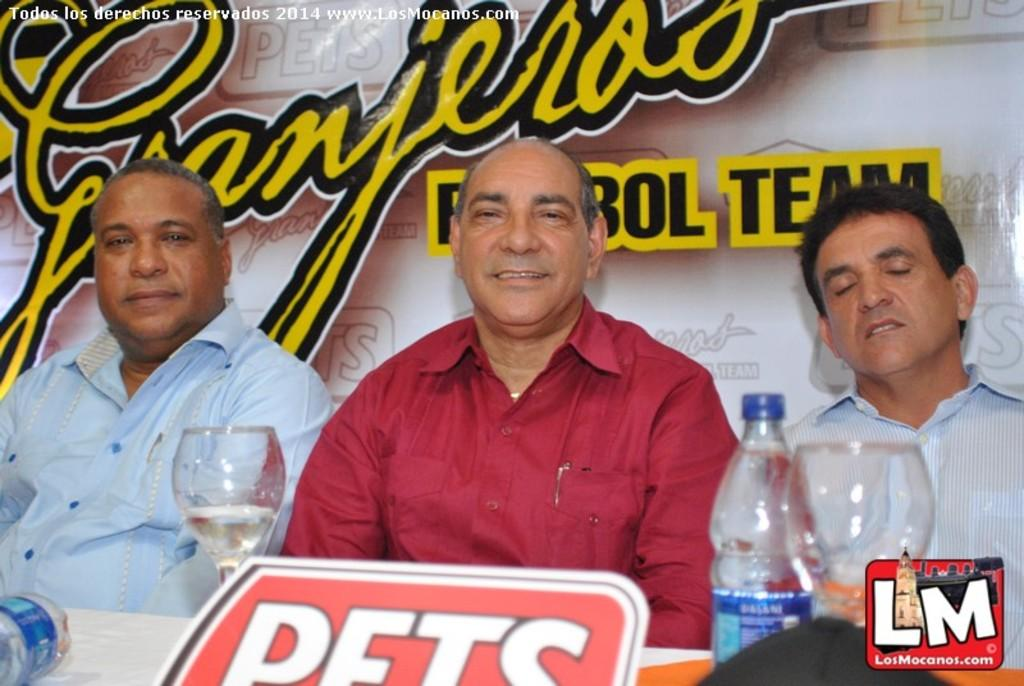Provide a one-sentence caption for the provided image. Three men with with a Granjeros sign behind them. 